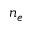Convert formula to latex. <formula><loc_0><loc_0><loc_500><loc_500>n _ { e }</formula> 